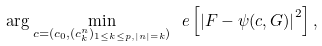Convert formula to latex. <formula><loc_0><loc_0><loc_500><loc_500>\arg \min _ { c = ( c _ { 0 } , ( c ^ { n } _ { k } ) _ { 1 \leq k \leq p , | n | = k } ) } \ e \left [ \left | F - \psi ( c , G ) \right | ^ { 2 } \right ] ,</formula> 